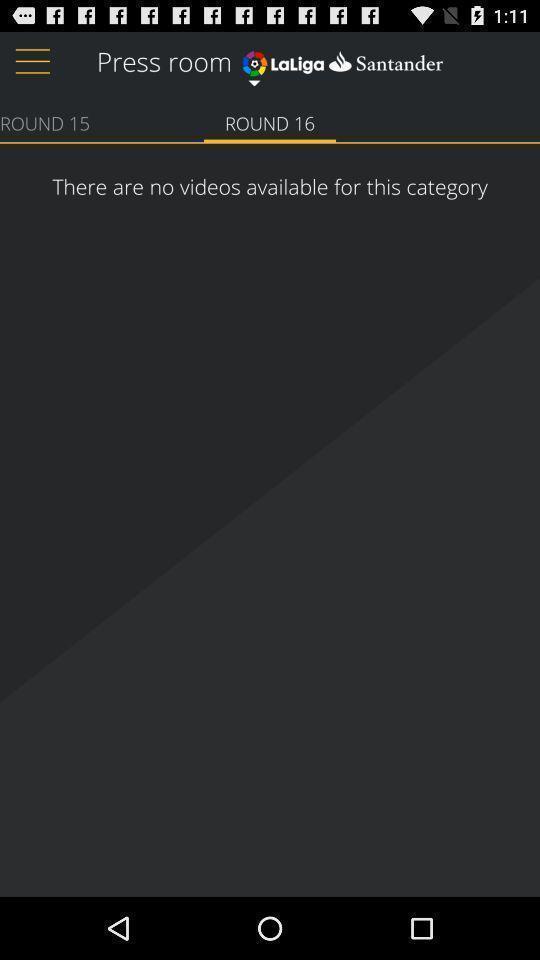Describe this image in words. Screen displaying videos page of a sports app. 